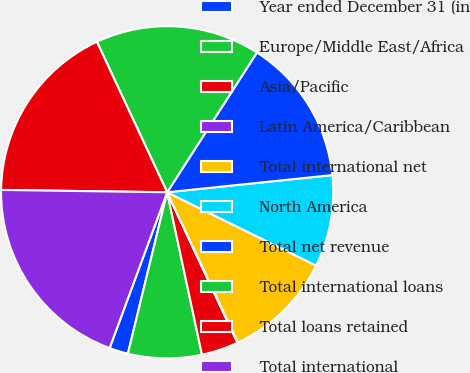Convert chart. <chart><loc_0><loc_0><loc_500><loc_500><pie_chart><fcel>Year ended December 31 (in<fcel>Europe/Middle East/Africa<fcel>Asia/Pacific<fcel>Latin America/Caribbean<fcel>Total international net<fcel>North America<fcel>Total net revenue<fcel>Total international loans<fcel>Total loans retained<fcel>Total international<nl><fcel>1.83%<fcel>7.16%<fcel>3.6%<fcel>0.05%<fcel>10.71%<fcel>8.93%<fcel>14.26%<fcel>16.04%<fcel>17.82%<fcel>19.59%<nl></chart> 